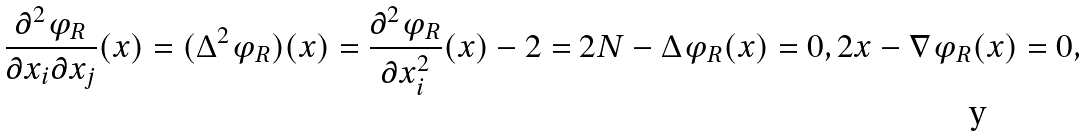<formula> <loc_0><loc_0><loc_500><loc_500>\frac { \partial ^ { 2 } \varphi _ { R } } { \partial x _ { i } \partial x _ { j } } ( x ) = ( \Delta ^ { 2 } \varphi _ { R } ) ( x ) = \frac { \partial ^ { 2 } \varphi _ { R } } { \partial x _ { i } ^ { 2 } } ( x ) - 2 = 2 N - \Delta \varphi _ { R } ( x ) = 0 , 2 x - \nabla \varphi _ { R } ( x ) = 0 ,</formula> 